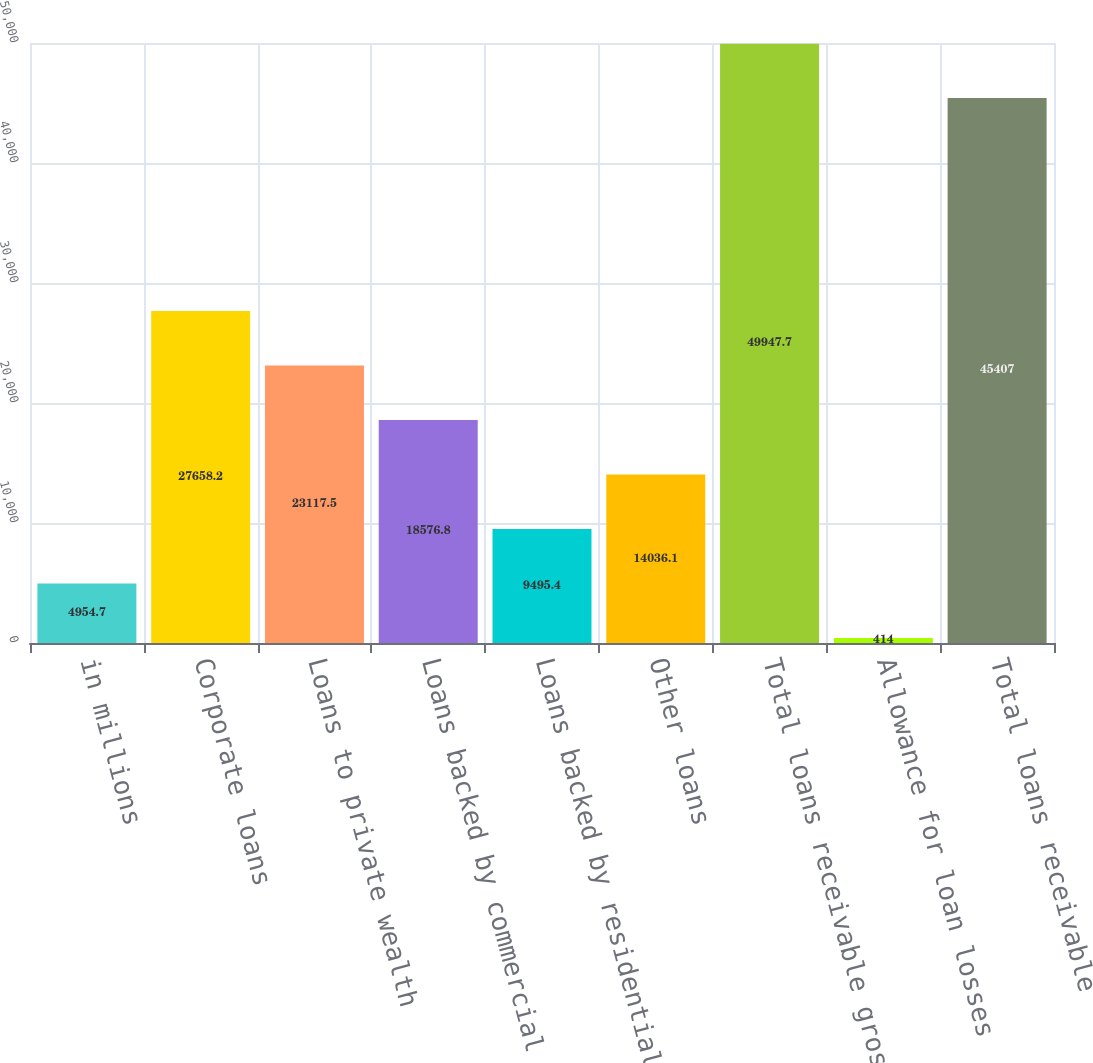Convert chart to OTSL. <chart><loc_0><loc_0><loc_500><loc_500><bar_chart><fcel>in millions<fcel>Corporate loans<fcel>Loans to private wealth<fcel>Loans backed by commercial<fcel>Loans backed by residential<fcel>Other loans<fcel>Total loans receivable gross<fcel>Allowance for loan losses<fcel>Total loans receivable<nl><fcel>4954.7<fcel>27658.2<fcel>23117.5<fcel>18576.8<fcel>9495.4<fcel>14036.1<fcel>49947.7<fcel>414<fcel>45407<nl></chart> 